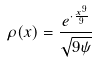Convert formula to latex. <formula><loc_0><loc_0><loc_500><loc_500>\rho ( x ) = \frac { e ^ { \cdot \frac { x ^ { 9 } } { 9 } } } { \sqrt { 9 \psi } }</formula> 